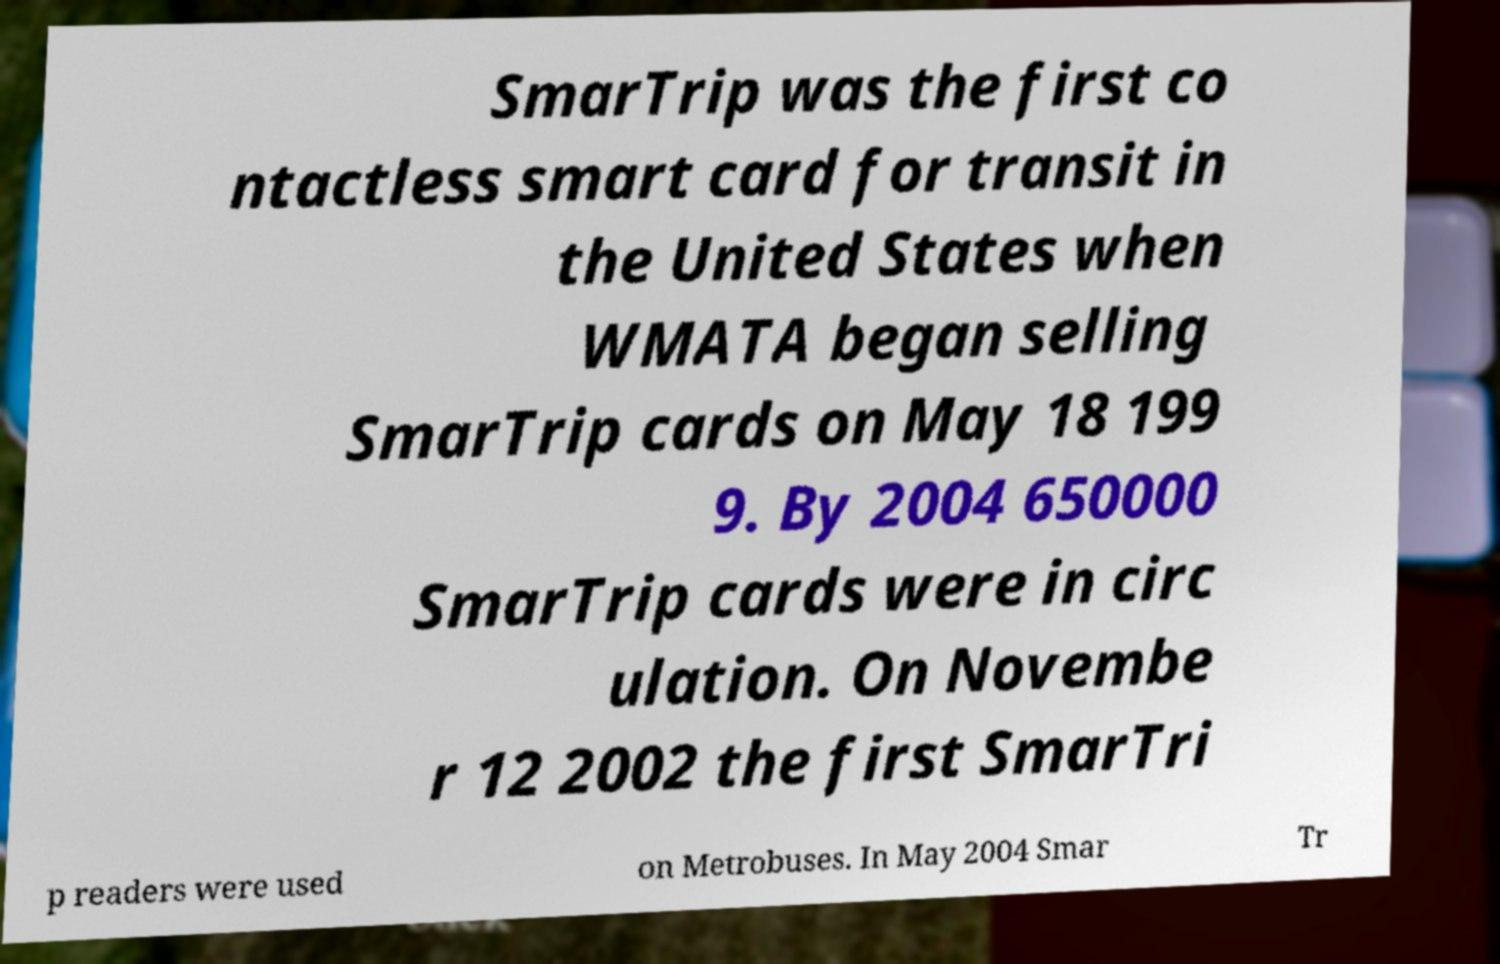What messages or text are displayed in this image? I need them in a readable, typed format. SmarTrip was the first co ntactless smart card for transit in the United States when WMATA began selling SmarTrip cards on May 18 199 9. By 2004 650000 SmarTrip cards were in circ ulation. On Novembe r 12 2002 the first SmarTri p readers were used on Metrobuses. In May 2004 Smar Tr 